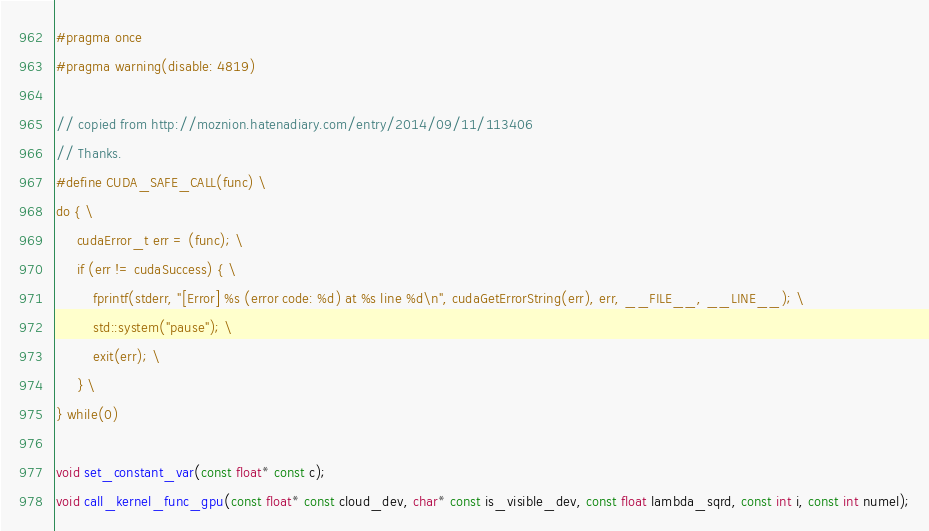Convert code to text. <code><loc_0><loc_0><loc_500><loc_500><_Cuda_>#pragma once
#pragma warning(disable: 4819)

// copied from http://moznion.hatenadiary.com/entry/2014/09/11/113406
// Thanks.
#define CUDA_SAFE_CALL(func) \
do { \
     cudaError_t err = (func); \
     if (err != cudaSuccess) { \
         fprintf(stderr, "[Error] %s (error code: %d) at %s line %d\n", cudaGetErrorString(err), err, __FILE__, __LINE__); \
         std::system("pause"); \
         exit(err); \
     } \
} while(0)

void set_constant_var(const float* const c);
void call_kernel_func_gpu(const float* const cloud_dev, char* const is_visible_dev, const float lambda_sqrd, const int i, const int numel);
</code> 